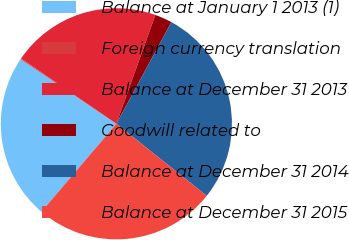<chart> <loc_0><loc_0><loc_500><loc_500><pie_chart><fcel>Balance at January 1 2013 (1)<fcel>Foreign currency translation<fcel>Balance at December 31 2013<fcel>Goodwill related to<fcel>Balance at December 31 2014<fcel>Balance at December 31 2015<nl><fcel>23.21%<fcel>0.12%<fcel>20.91%<fcel>2.42%<fcel>27.82%<fcel>25.52%<nl></chart> 